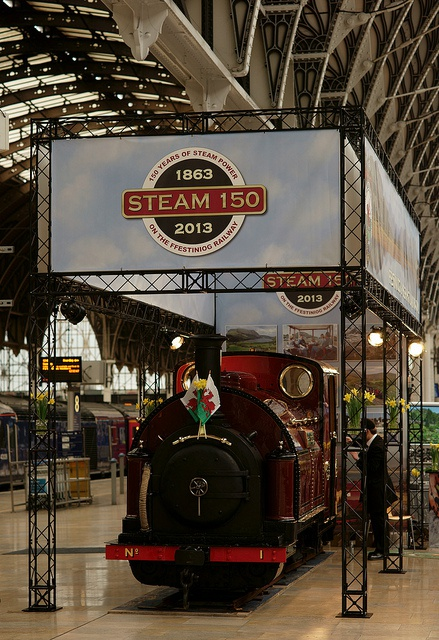Describe the objects in this image and their specific colors. I can see train in black, maroon, and gray tones, train in black, gray, and maroon tones, and people in black, maroon, and gray tones in this image. 